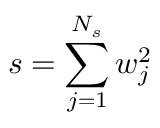Convert formula to latex. <formula><loc_0><loc_0><loc_500><loc_500>s = \sum _ { j = 1 } ^ { N _ { s } } w _ { j } ^ { 2 }</formula> 